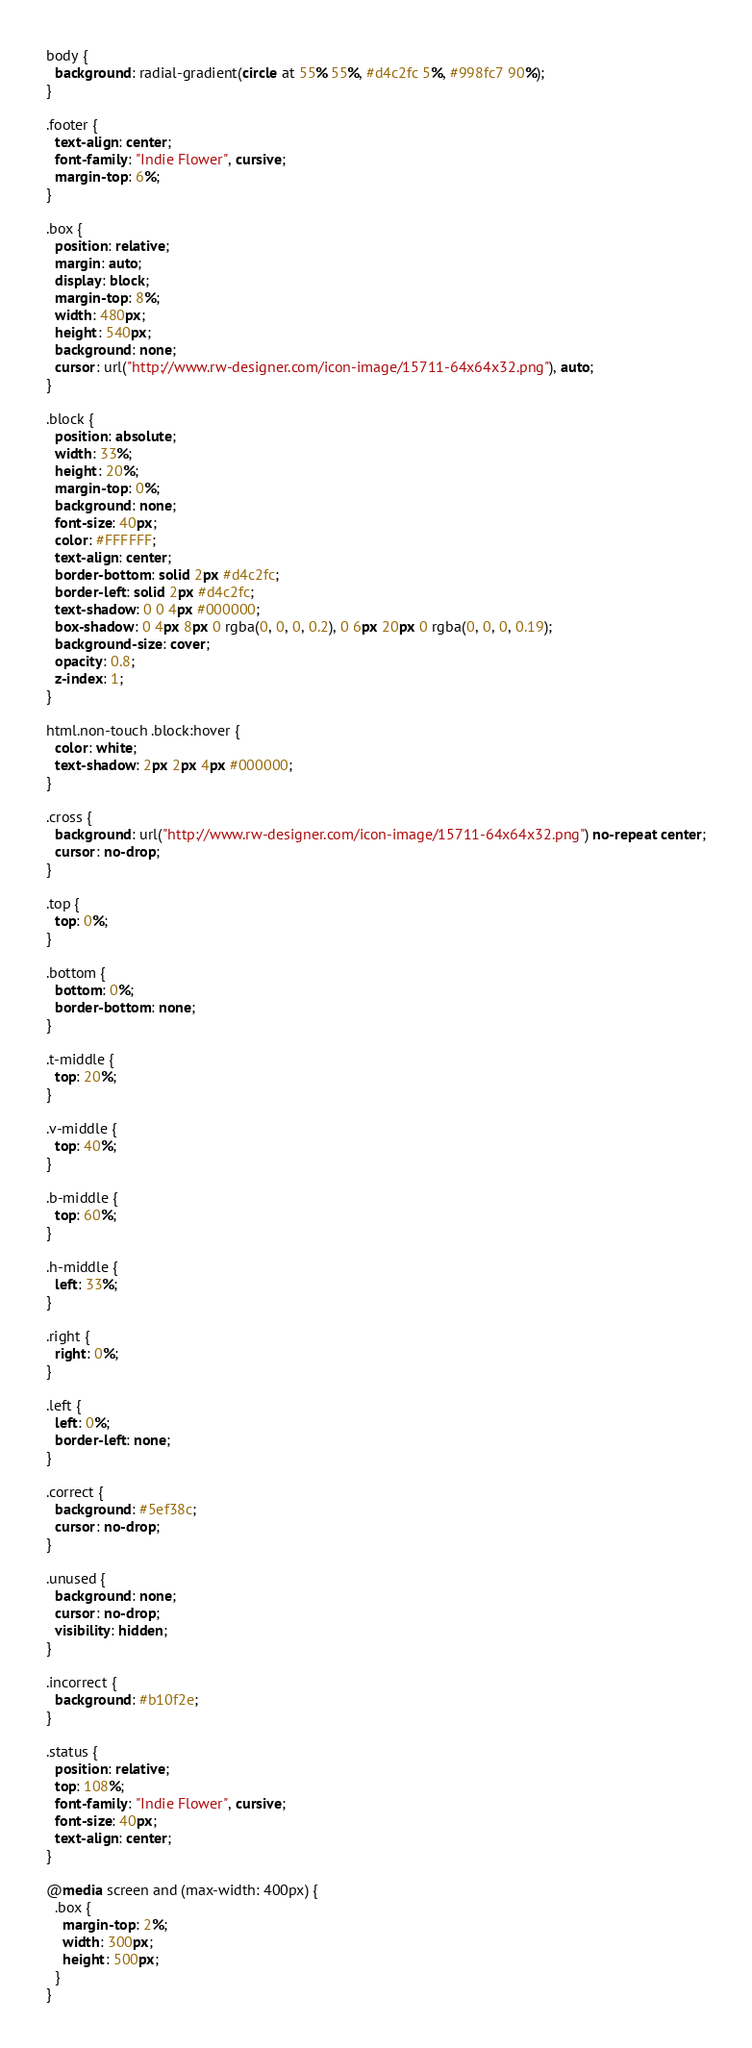Convert code to text. <code><loc_0><loc_0><loc_500><loc_500><_CSS_>body {
  background: radial-gradient(circle at 55% 55%, #d4c2fc 5%, #998fc7 90%);
}

.footer {
  text-align: center;
  font-family: "Indie Flower", cursive;
  margin-top: 6%;
}

.box {
  position: relative;
  margin: auto;
  display: block;
  margin-top: 8%;
  width: 480px;
  height: 540px;
  background: none;
  cursor: url("http://www.rw-designer.com/icon-image/15711-64x64x32.png"), auto;
}

.block {
  position: absolute;
  width: 33%;
  height: 20%;
  margin-top: 0%;
  background: none;
  font-size: 40px;
  color: #FFFFFF;
  text-align: center;
  border-bottom: solid 2px #d4c2fc;
  border-left: solid 2px #d4c2fc;
  text-shadow: 0 0 4px #000000;
  box-shadow: 0 4px 8px 0 rgba(0, 0, 0, 0.2), 0 6px 20px 0 rgba(0, 0, 0, 0.19);
  background-size: cover;
  opacity: 0.8;
  z-index: 1;
}

html.non-touch .block:hover {
  color: white;
  text-shadow: 2px 2px 4px #000000;
}

.cross {
  background: url("http://www.rw-designer.com/icon-image/15711-64x64x32.png") no-repeat center;
  cursor: no-drop;
}

.top {
  top: 0%;
}

.bottom {
  bottom: 0%;
  border-bottom: none;
}

.t-middle {
  top: 20%;
}

.v-middle {
  top: 40%;
}

.b-middle {
  top: 60%;
}

.h-middle {
  left: 33%;
}

.right {
  right: 0%;
}

.left {
  left: 0%;
  border-left: none;
}

.correct {
  background: #5ef38c;
  cursor: no-drop;
}

.unused {
  background: none;
  cursor: no-drop;
  visibility: hidden;
}

.incorrect {
  background: #b10f2e;
}

.status {
  position: relative;
  top: 108%;
  font-family: "Indie Flower", cursive;
  font-size: 40px;
  text-align: center;
}

@media screen and (max-width: 400px) {
  .box {
    margin-top: 2%;
    width: 300px;
    height: 500px;
  }
}
</code> 